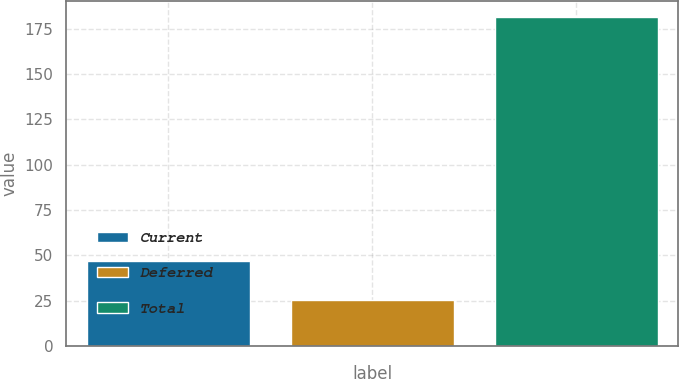Convert chart to OTSL. <chart><loc_0><loc_0><loc_500><loc_500><bar_chart><fcel>Current<fcel>Deferred<fcel>Total<nl><fcel>46.9<fcel>25.2<fcel>181.2<nl></chart> 